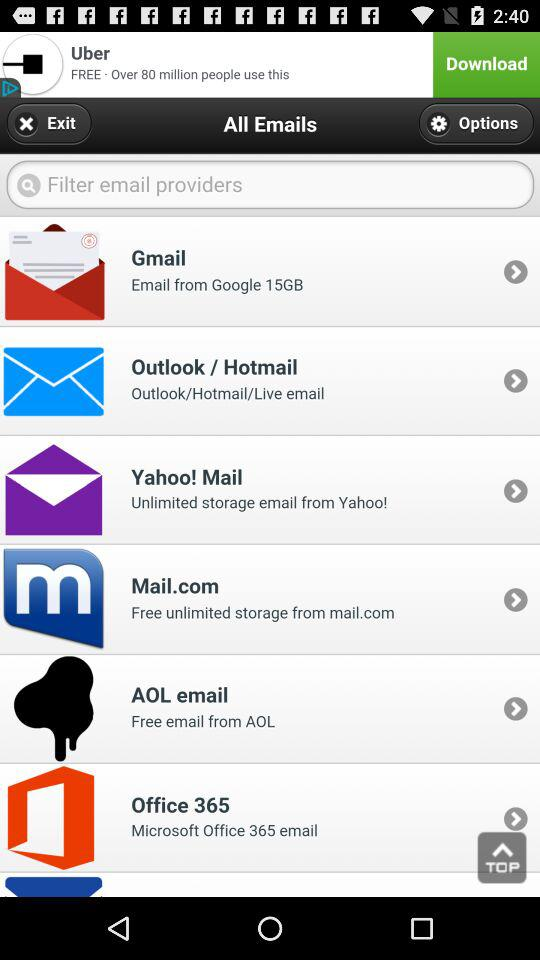What is the number of emails in Office 365?
When the provided information is insufficient, respond with <no answer>. <no answer> 